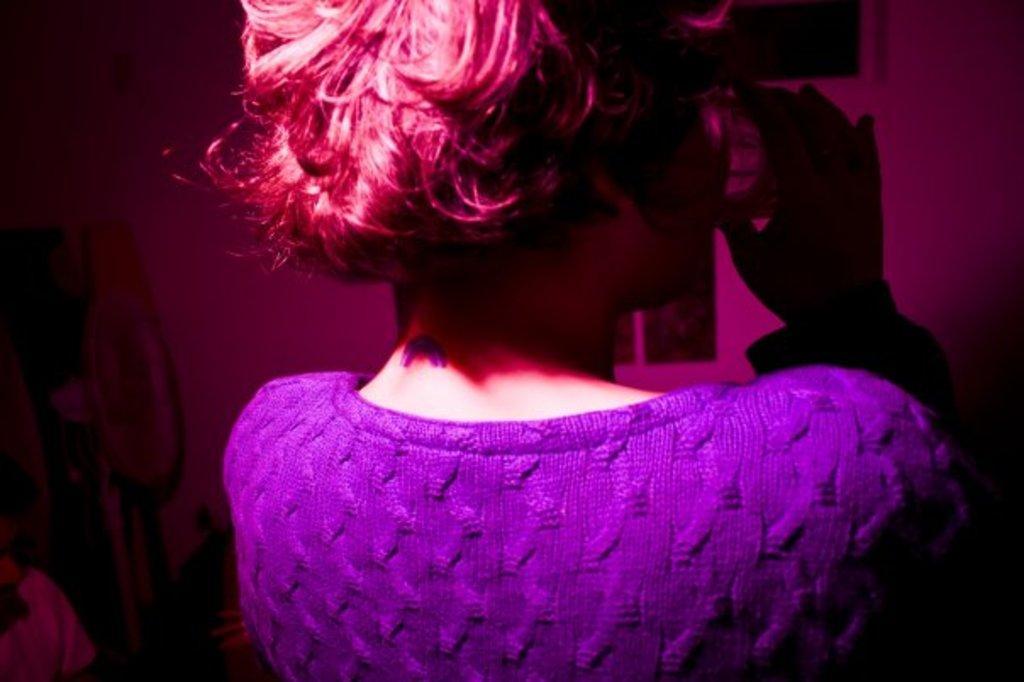How would you summarize this image in a sentence or two? In this image we can see a lady holding a glass. In the background of the image there is a wall. 